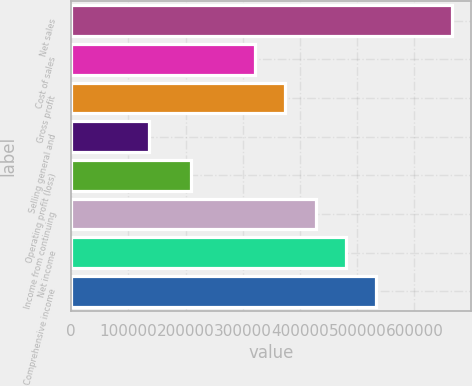Convert chart. <chart><loc_0><loc_0><loc_500><loc_500><bar_chart><fcel>Net sales<fcel>Cost of sales<fcel>Gross profit<fcel>Selling general and<fcel>Operating profit (loss)<fcel>Income from continuing<fcel>Net income<fcel>Comprehensive income<nl><fcel>666270<fcel>321305<fcel>374298<fcel>136336<fcel>208629<fcel>427292<fcel>480285<fcel>533279<nl></chart> 